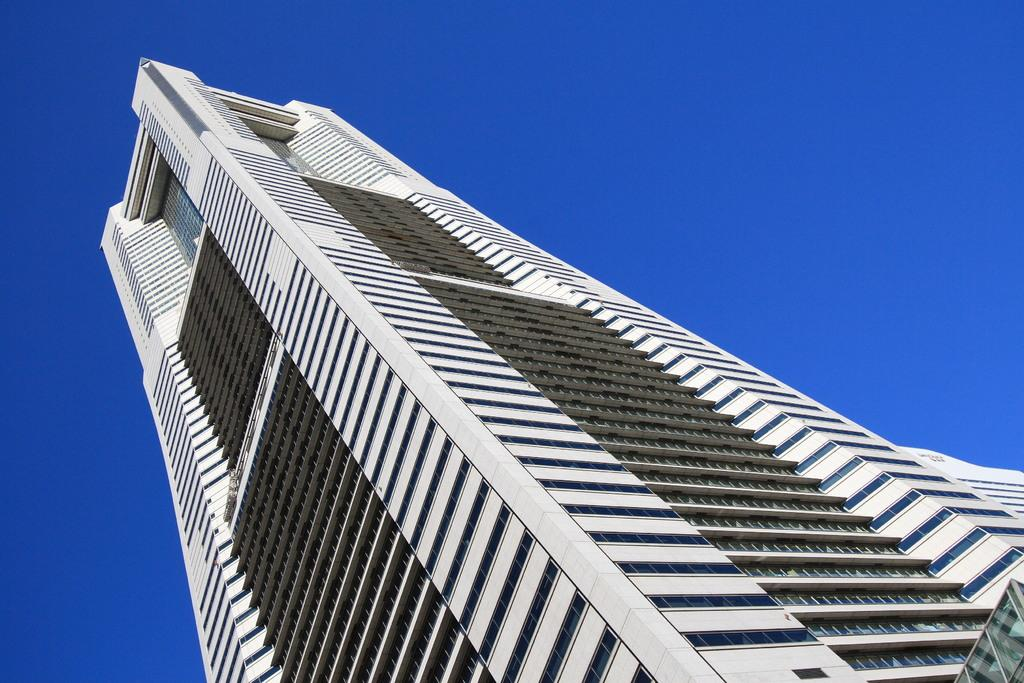What is the main subject in the middle of the image? There is a building in the middle of the image. What can be seen in the background of the image? The sky is blue in the background of the image. What type of basket is hanging from the building in the image? There is no basket hanging from the building in the image. What kind of loaf can be seen being baked in the building? There is no loaf or baking activity visible in the image. 